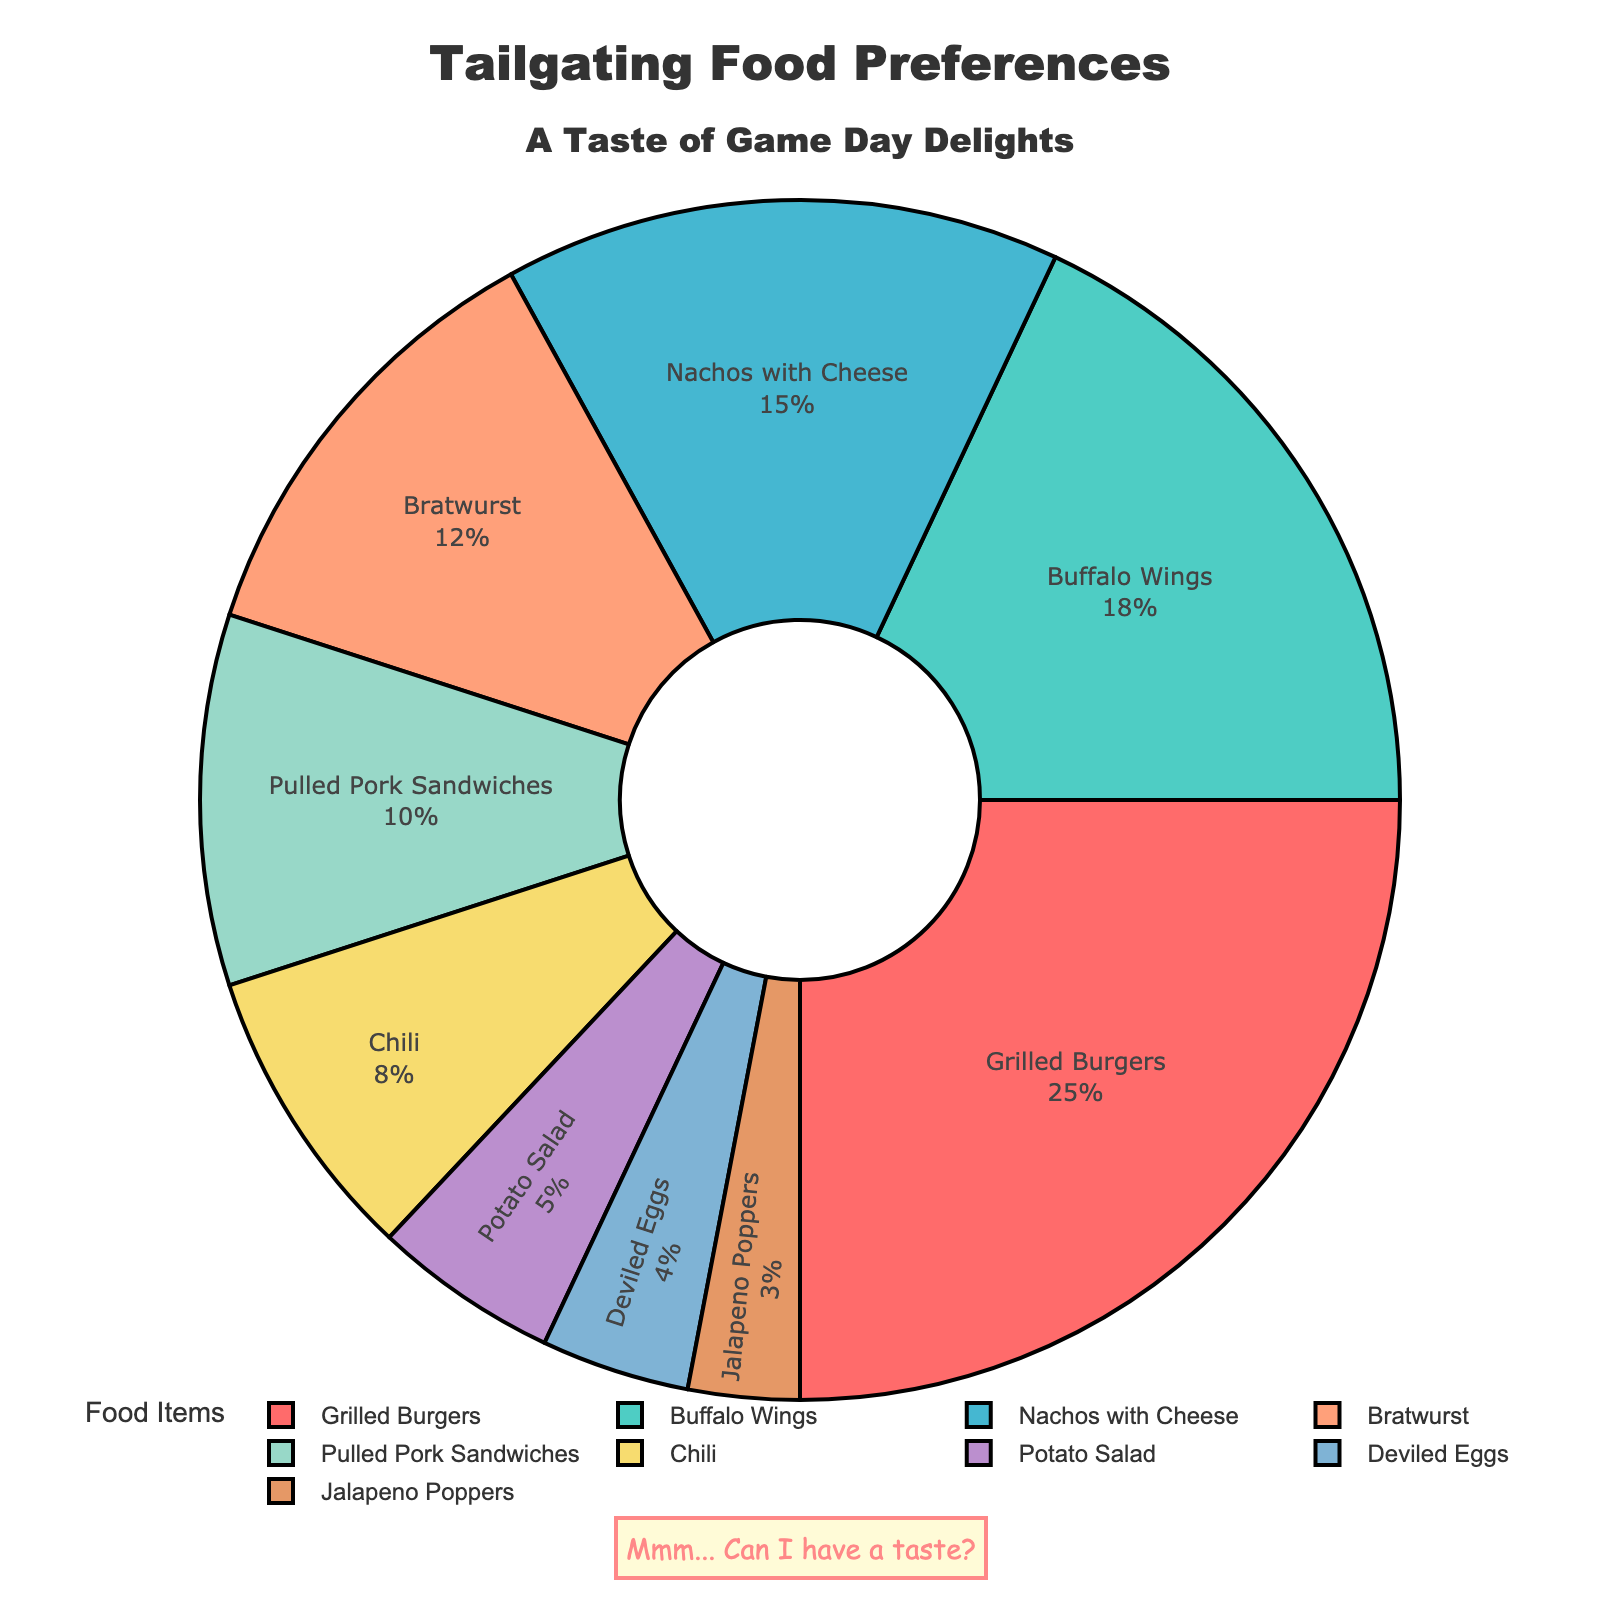What percentage of fans prefer Grilled Burgers? Refer to the slice labeled "Grilled Burgers" in the pie chart, which indicates 25%.
Answer: 25% How many percentage points more do fans prefer Buffalo Wings over Bratwurst? Locate the slices labeled "Buffalo Wings" and "Bratwurst." Buffalo Wings have 18%, and Bratwurst has 12%. Subtract 12 from 18: 18 - 12 = 6.
Answer: 6 Which food item is the least popular among the fans? Identify the smallest slice by its size and label. "Jalapeno Poppers" is the smallest with 3%.
Answer: Jalapeno Poppers Do fans prefer Potato Salad or Deviled Eggs more, and by how much? Compare the slices labeled "Potato Salad" (5%) and "Deviled Eggs" (4%). Subtract 4 from 5: 5 - 4 = 1.
Answer: Potato Salad, by 1% If Nachos with Cheese and Chili preferences are combined, what percentage do they represent? Locate the slices labeled "Nachos with Cheese" (15%) and "Chili" (8%). Add these percentages together: 15 + 8 = 23.
Answer: 23% What is the combined percentage of fans who prefer either Grilled Burgers, Buffalo Wings, or Pulled Pork Sandwiches? Find the slices for Grilled Burgers (25%), Buffalo Wings (18%), and Pulled Pork Sandwiches (10%). Add them: 25 + 18 + 10 = 53.
Answer: 53% Which food item has a purple slice in the pie chart? Identify the slice with a purple color and its label, which is "Bratwurst" (12%).
Answer: Bratwurst By how many percentage points do Grilled Burgers exceed Nachos with Cheese? Compare the percentages of Grilled Burgers (25%) and Nachos with Cheese (15%). Subtract 15 from 25: 25 - 15 = 10.
Answer: 10 Which food items make up less than 10% each? Identify slices with percentages under 10%. These are Chili (8%), Potato Salad (5%), Deviled Eggs (4%), and Jalapeno Poppers (3%).
Answer: Chili, Potato Salad, Deviled Eggs, Jalapeno Poppers What is the average percentage of fans who prefer Bratwurst, Pulled Pork Sandwiches, and Chili? Find and add the percentages of Bratwurst (12%), Pulled Pork Sandwiches (10%), and Chili (8%): 12 + 10 + 8 = 30. Divide by 3 to get the average: 30 / 3 = 10.
Answer: 10 